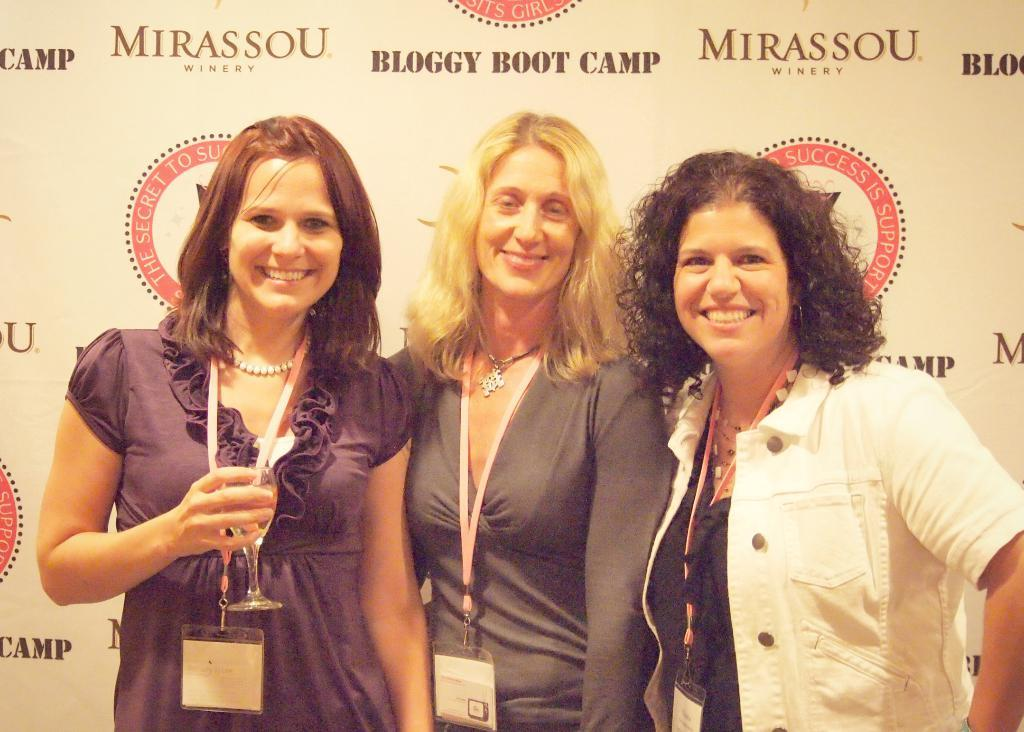How many women are present in the image? There are three women in the image. What are the women wearing that identifies them? The women are wearing identity cards. What are the women doing in the image? The women are standing and smiling. What can be seen in the background of the image? There is a huge banner in the background of the image. What type of hair is the rake using to apply the poison in the image? There is no rake, hair, or poison present in the image. 